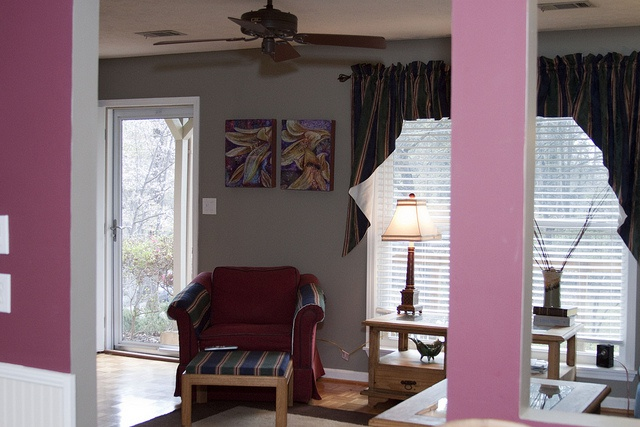Describe the objects in this image and their specific colors. I can see chair in purple, black, gray, maroon, and brown tones, dining table in purple, darkgray, and lightgray tones, vase in purple, gray, black, and maroon tones, book in purple, black, lightgray, and darkgray tones, and book in purple, gray, lightgray, and darkgray tones in this image. 